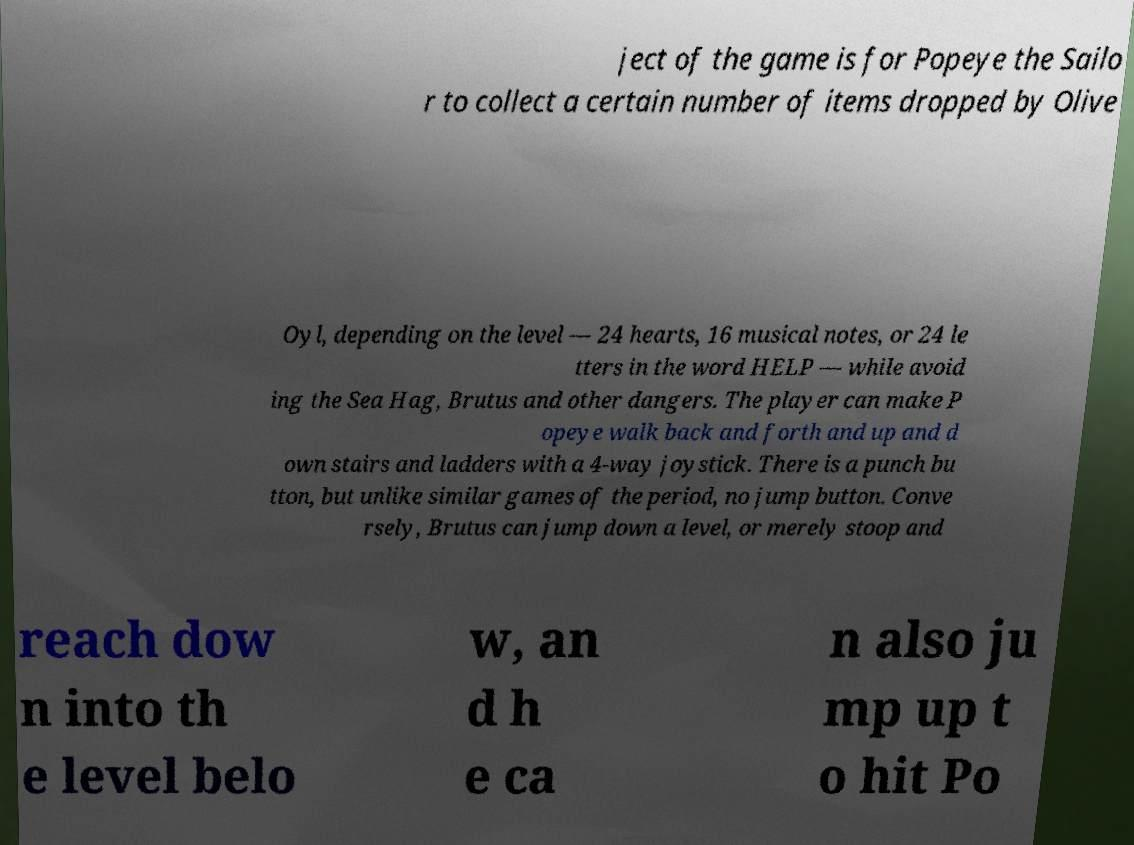I need the written content from this picture converted into text. Can you do that? ject of the game is for Popeye the Sailo r to collect a certain number of items dropped by Olive Oyl, depending on the level — 24 hearts, 16 musical notes, or 24 le tters in the word HELP — while avoid ing the Sea Hag, Brutus and other dangers. The player can make P opeye walk back and forth and up and d own stairs and ladders with a 4-way joystick. There is a punch bu tton, but unlike similar games of the period, no jump button. Conve rsely, Brutus can jump down a level, or merely stoop and reach dow n into th e level belo w, an d h e ca n also ju mp up t o hit Po 